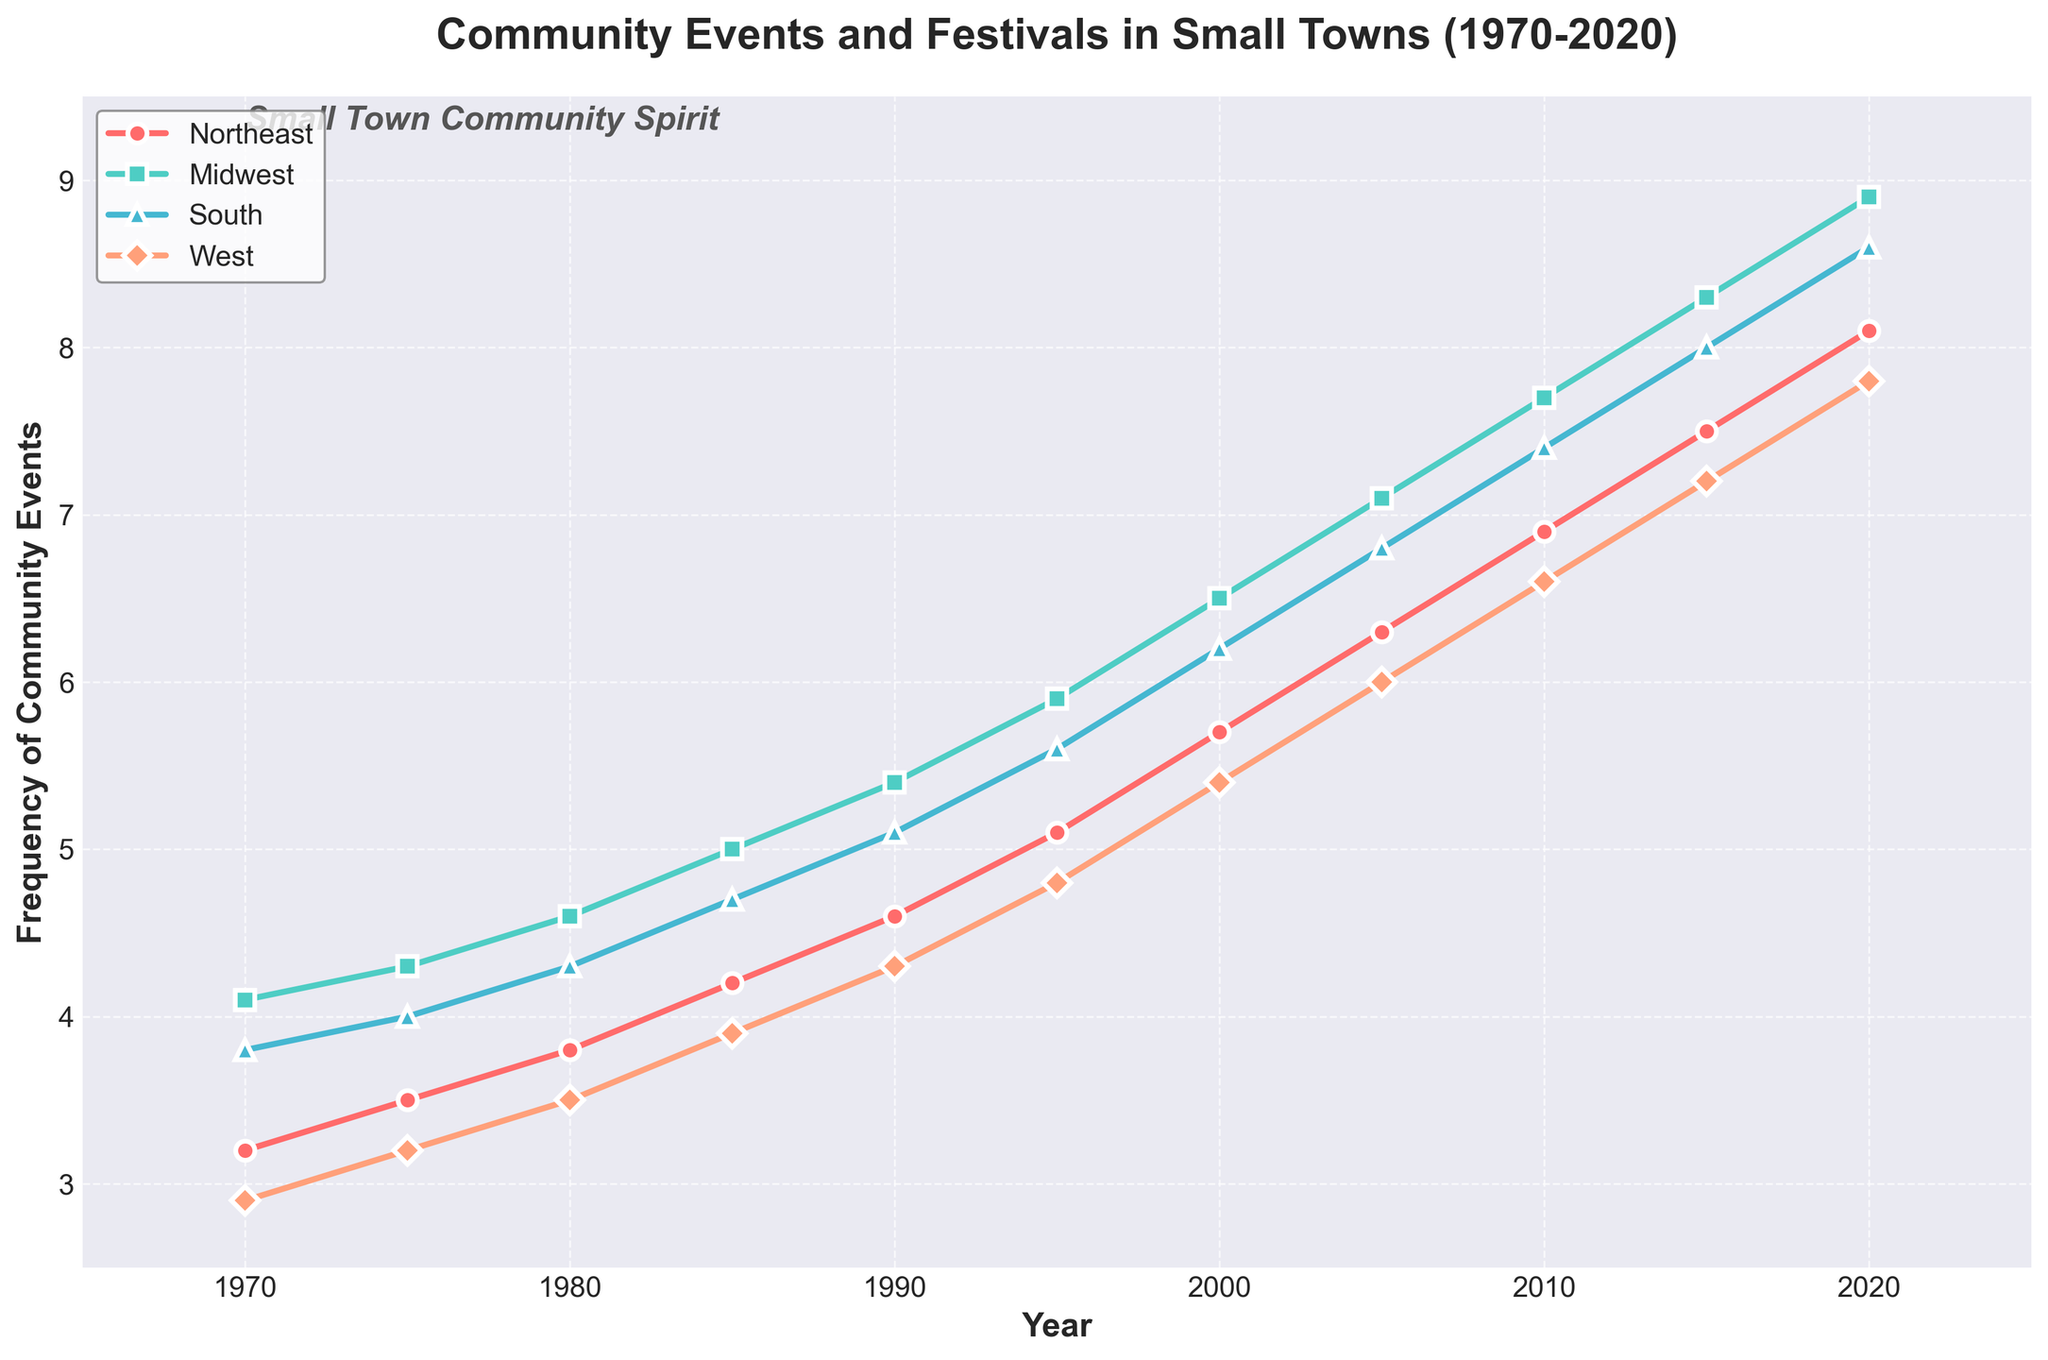What is the frequency of community events in the Midwest region in 1990? Find the year "1990" on the x-axis and identify the corresponding y value for the "Midwest" region, which is indicated by the green line.
Answer: 5.4 Which region had the highest frequency of community events in 2020? Look at the y-values for all regions in 2020 and identify the highest value. The regions are marked with different shapes and colors.
Answer: Northeast Between 1980 and 1990, which region showed the greatest increase in the frequency of community events? Calculate the difference in frequency for each region between 1980 and 1990. Northeast: 4.6-3.8=0.8, Midwest: 5.4-4.6=0.8, South: 5.1-4.3=0.8, West: 4.3-3.5=0.8. All increases are equal.
Answer: All regions What is the difference in the frequency of community events between the Northeast and the West in 2015? Identify the y-values for the Northeast and West in 2015: Northeast (7.5) and West (7.2). Subtract the value for the West from the value for the Northeast.
Answer: 0.3 Which year shows the smallest difference in the frequency of community events between the South and the Midwest? Calculate the differences between the South and Midwest for each year and identify the smallest difference. 1970: 4.1-3.8=0.3, 1975: 4.3-4.0=0.3, 1980: 4.6-4.3=0.3, 1985: 5.0-4.7=0.3, 1990: 5.4-5.1=0.3, 1995: 5.9-5.6=0.3, 2000: 6.5-6.2=0.3, 2005: 7.1-6.8=0.3, 2010: 7.7-7.4=0.3, 2015: 8.3-8.0=0.3, 2020: 8.9-8.6=0.3. The differences are the same (0.3) for all years.
Answer: All years From 1970 to 2020, which region consistently had the lowest frequency of community events? Identify the region with the lowest y-values in each year and determine if any region consistently has the lowest values.
Answer: West What was the average frequency of community events in the South from 2000 to 2020? Sum the frequencies for the South from 2000 (6.2), 2005 (6.8), 2010 (7.4), 2015 (8.0), and 2020 (8.6) and divide by the number of years (5). Sum = 6.2 + 6.8 + 7.4 + 8.0 + 8.6 = 37. Average = 37/5.
Answer: 7.4 By how much did the frequency of community events increase in the Northeast region from 1970 to 2020? Subtract the frequency in 1970 from the frequency in 2020 for the Northeast region. 2020: 8.1, 1970: 3.2. Difference = 8.1 - 3.2.
Answer: 4.9 